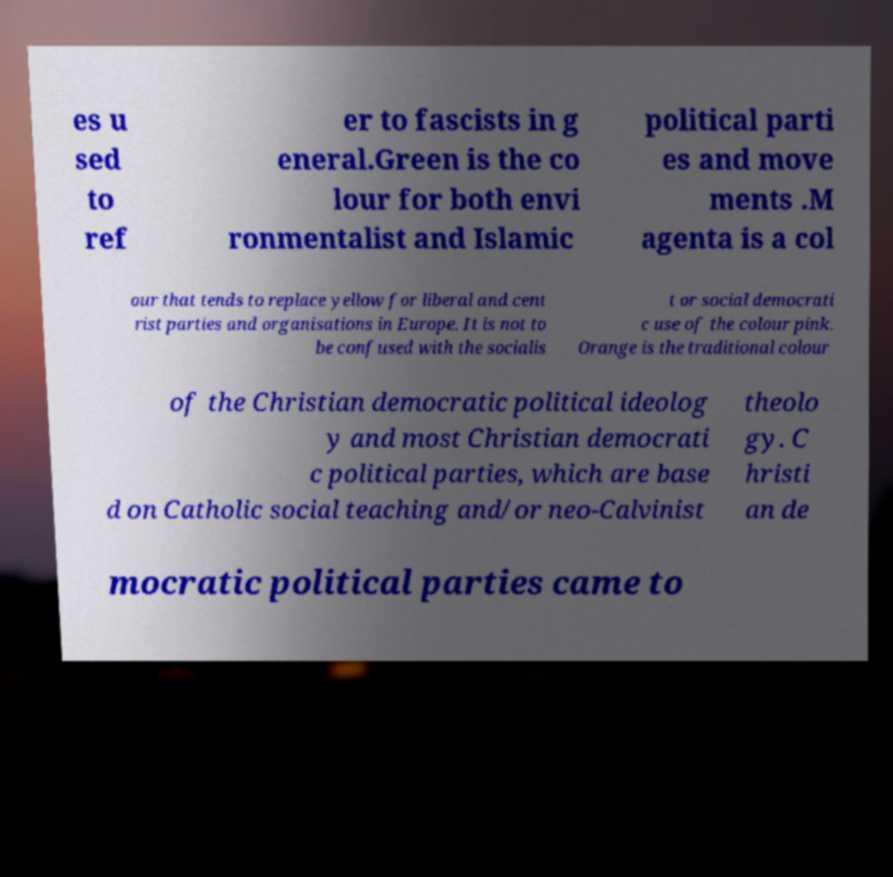Please read and relay the text visible in this image. What does it say? es u sed to ref er to fascists in g eneral.Green is the co lour for both envi ronmentalist and Islamic political parti es and move ments .M agenta is a col our that tends to replace yellow for liberal and cent rist parties and organisations in Europe. It is not to be confused with the socialis t or social democrati c use of the colour pink. Orange is the traditional colour of the Christian democratic political ideolog y and most Christian democrati c political parties, which are base d on Catholic social teaching and/or neo-Calvinist theolo gy. C hristi an de mocratic political parties came to 